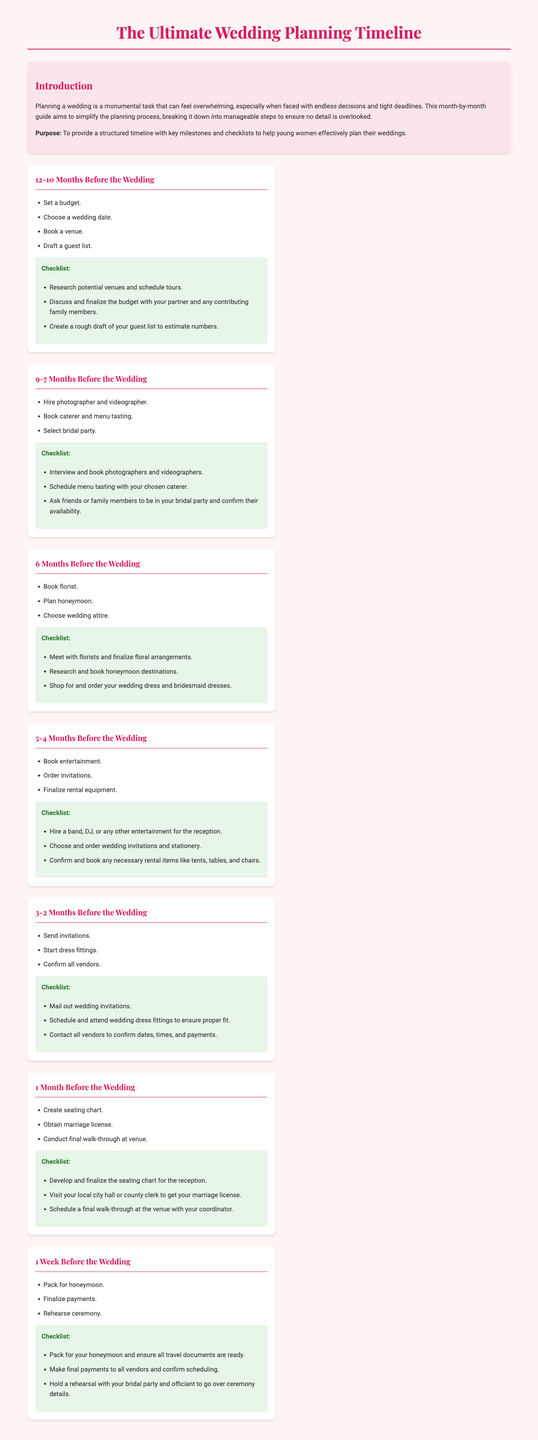What is the purpose of the document? The purpose is mentioned in the introduction, highlighting its goal to help users plan their weddings effectively.
Answer: To provide a structured timeline with key milestones and checklists to help young women effectively plan their weddings How many months before the wedding should you set a budget? According to the timeline, setting a budget is one of the first tasks to do, which occurs 12-10 months before the wedding.
Answer: 12-10 months What is one of the first tasks to do when planning a wedding? The document states that choosing a wedding date is listed as a crucial early task.
Answer: Choose a wedding date How many steps are outlined for the 3-2 months before the wedding? The number of tasks for this timeline can be calculated from the listed items in the section regarding 3-2 months before the wedding.
Answer: 3 What should you do one week before the wedding? From the timeline, the document mentions that one of the tasks is to pack for the honeymoon.
Answer: Pack for honeymoon What is the final task in the checklist of the 1 Week Before the Wedding milestone? The last item in the checklist for this period addresses a rehearsal with supportive personnel.
Answer: Hold a rehearsal with your bridal party and officiant What does the checklist for the 6 Months Before the Wedding milestone include? The document provides specific tasks related to this timeline like booking a florist and planning a honeymoon.
Answer: Book florist, Plan honeymoon, Choose wedding attire In what month should you start dress fittings? The timeline indicates that dress fittings should start 3-2 months before the wedding.
Answer: 3-2 months before What color scheme is used for the main heading of the document? The color of the main heading is described, which can be noted from the content styling.
Answer: #d81b60 